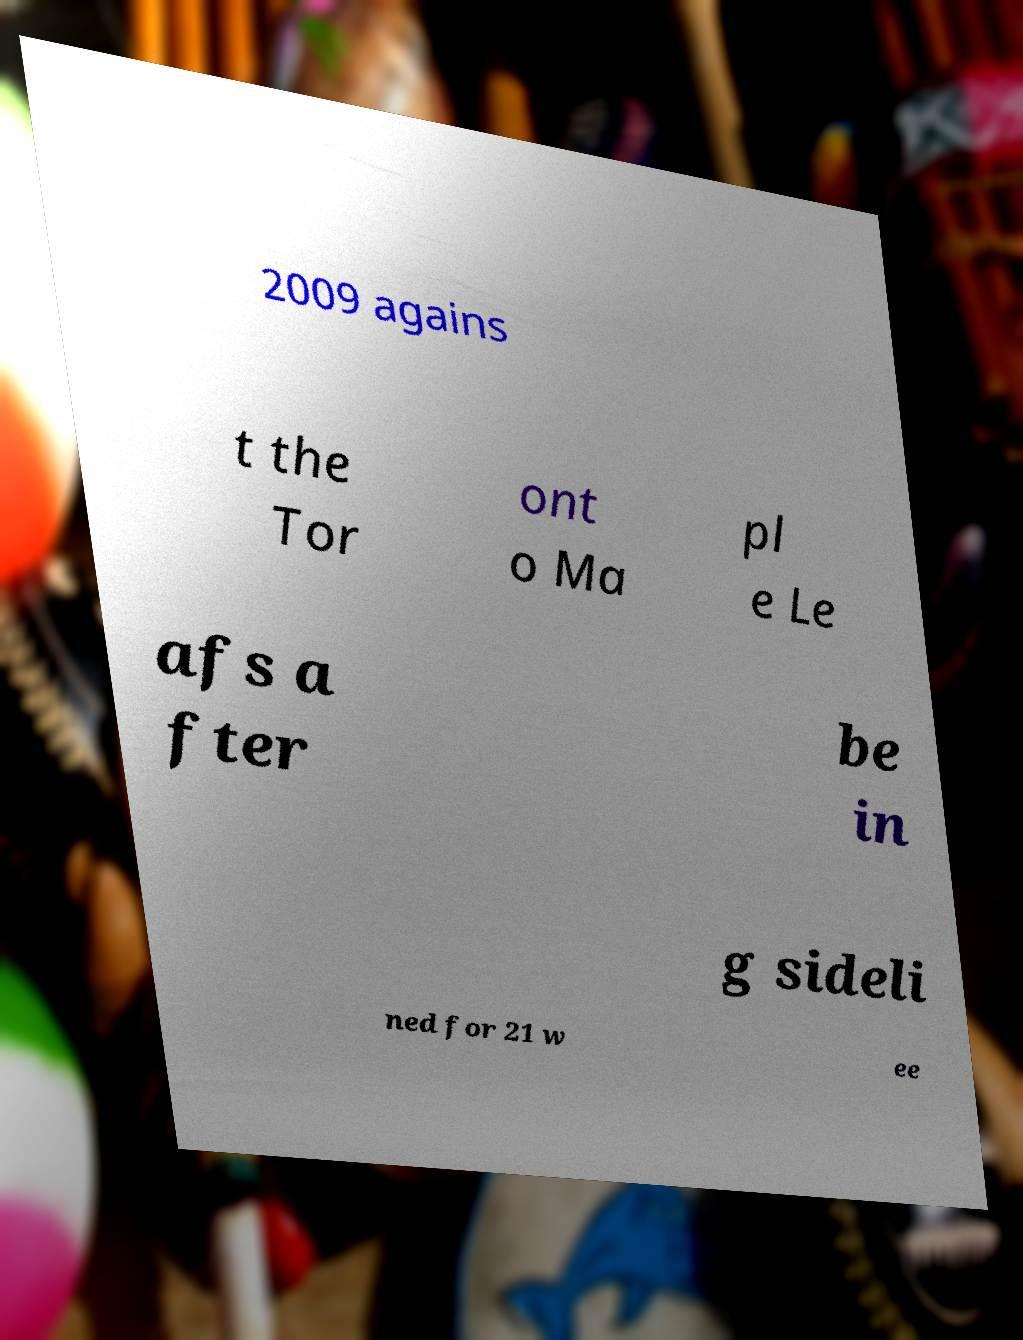Could you assist in decoding the text presented in this image and type it out clearly? 2009 agains t the Tor ont o Ma pl e Le afs a fter be in g sideli ned for 21 w ee 